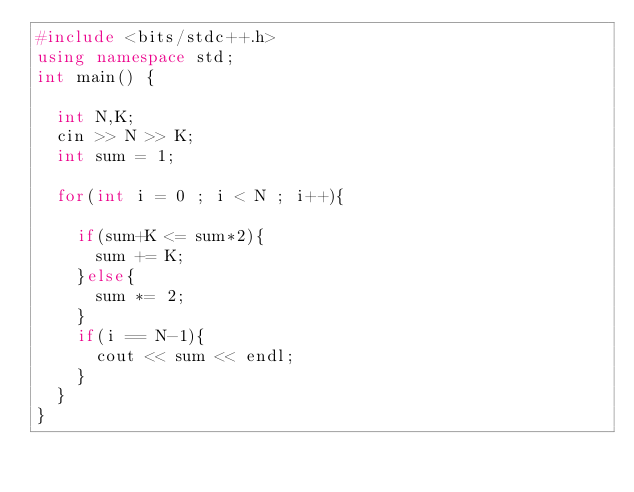Convert code to text. <code><loc_0><loc_0><loc_500><loc_500><_C++_>#include <bits/stdc++.h>
using namespace std;
int main() {
  
  int N,K;
  cin >> N >> K;
  int sum = 1;
  
  for(int i = 0 ; i < N ; i++){
    
    if(sum+K <= sum*2){
      sum += K;
    }else{
      sum *= 2;
    }
    if(i == N-1){
      cout << sum << endl;
    }
  }
}
</code> 